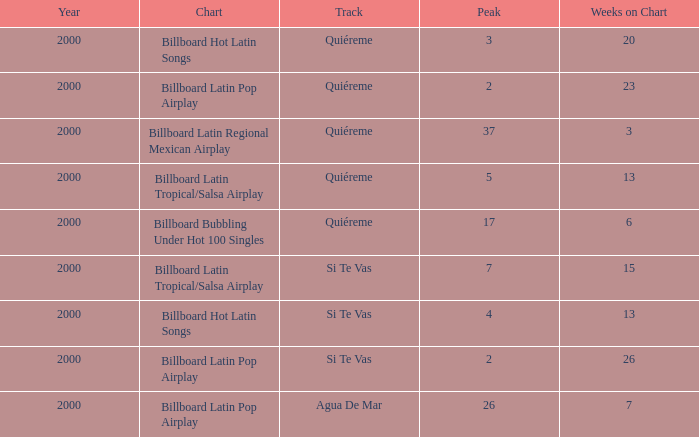Identify the smallest number of weeks in a year before 200 None. 